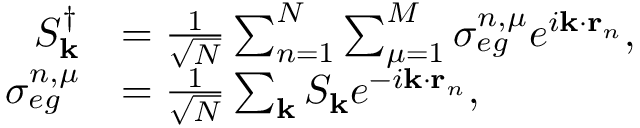<formula> <loc_0><loc_0><loc_500><loc_500>\begin{array} { r l } { S _ { k } ^ { \dagger } } & { = \frac { 1 } { \sqrt { N } } \sum _ { n = 1 } ^ { N } \sum _ { \mu = 1 } ^ { M } \sigma _ { e g } ^ { n , \mu } e ^ { i k \cdot r _ { n } } , } \\ { \sigma _ { e g } ^ { n , \mu } } & { = \frac { 1 } { \sqrt { N } } \sum _ { k } S _ { k } e ^ { - i k \cdot r _ { n } } , } \end{array}</formula> 